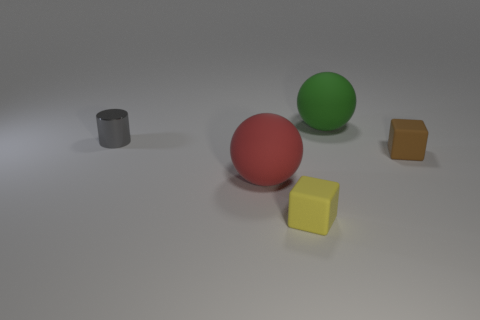Add 4 rubber spheres. How many objects exist? 9 Subtract all balls. How many objects are left? 3 Subtract 1 yellow cubes. How many objects are left? 4 Subtract all large cyan metallic blocks. Subtract all big red objects. How many objects are left? 4 Add 1 green matte spheres. How many green matte spheres are left? 2 Add 5 large red matte balls. How many large red matte balls exist? 6 